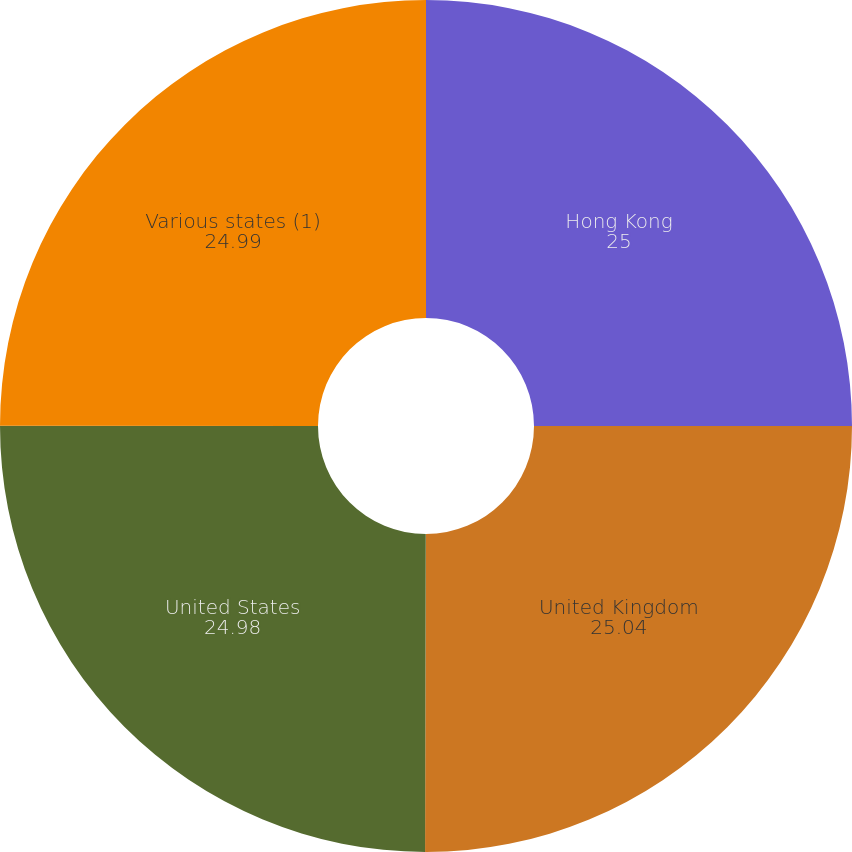<chart> <loc_0><loc_0><loc_500><loc_500><pie_chart><fcel>Hong Kong<fcel>United Kingdom<fcel>United States<fcel>Various states (1)<nl><fcel>25.0%<fcel>25.04%<fcel>24.98%<fcel>24.99%<nl></chart> 